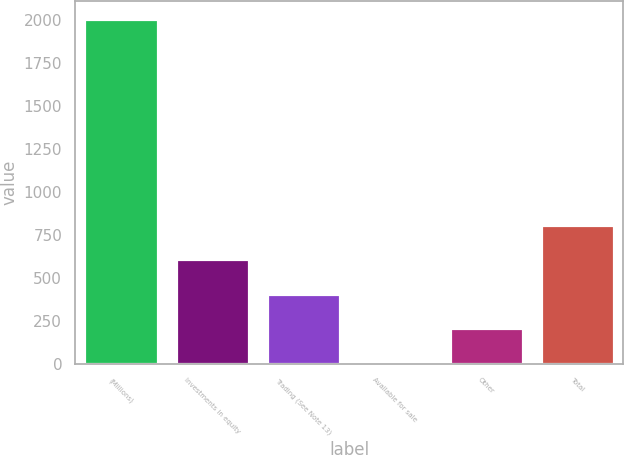Convert chart. <chart><loc_0><loc_0><loc_500><loc_500><bar_chart><fcel>(Millions)<fcel>Investments in equity<fcel>Trading (See Note 13)<fcel>Available for sale<fcel>Other<fcel>Total<nl><fcel>2005<fcel>607.8<fcel>408.2<fcel>9<fcel>208.6<fcel>807.4<nl></chart> 